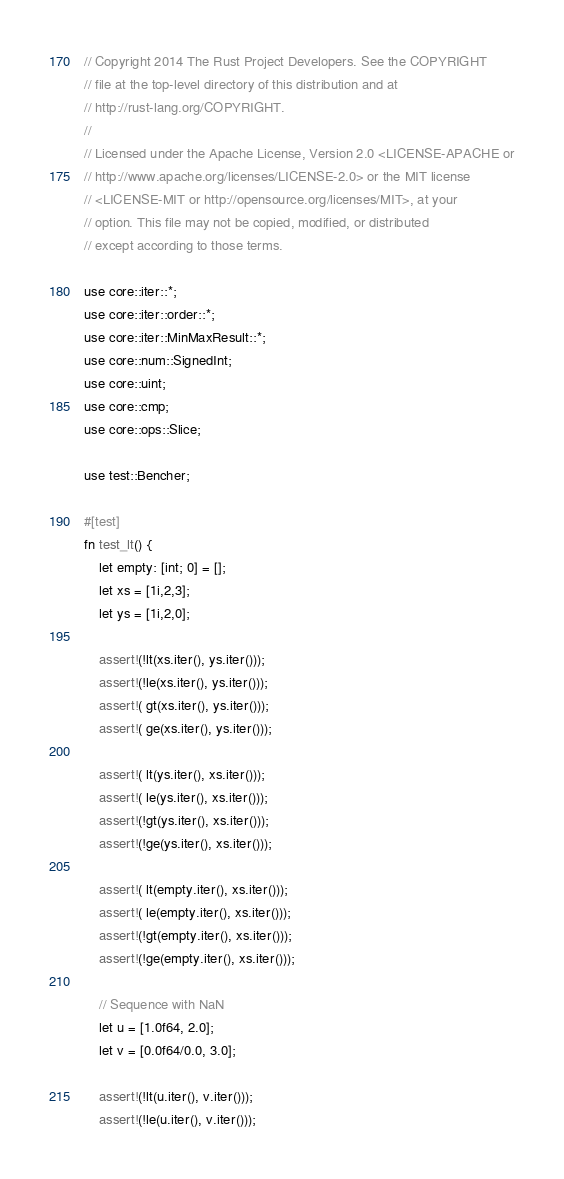Convert code to text. <code><loc_0><loc_0><loc_500><loc_500><_Rust_>// Copyright 2014 The Rust Project Developers. See the COPYRIGHT
// file at the top-level directory of this distribution and at
// http://rust-lang.org/COPYRIGHT.
//
// Licensed under the Apache License, Version 2.0 <LICENSE-APACHE or
// http://www.apache.org/licenses/LICENSE-2.0> or the MIT license
// <LICENSE-MIT or http://opensource.org/licenses/MIT>, at your
// option. This file may not be copied, modified, or distributed
// except according to those terms.

use core::iter::*;
use core::iter::order::*;
use core::iter::MinMaxResult::*;
use core::num::SignedInt;
use core::uint;
use core::cmp;
use core::ops::Slice;

use test::Bencher;

#[test]
fn test_lt() {
    let empty: [int; 0] = [];
    let xs = [1i,2,3];
    let ys = [1i,2,0];

    assert!(!lt(xs.iter(), ys.iter()));
    assert!(!le(xs.iter(), ys.iter()));
    assert!( gt(xs.iter(), ys.iter()));
    assert!( ge(xs.iter(), ys.iter()));

    assert!( lt(ys.iter(), xs.iter()));
    assert!( le(ys.iter(), xs.iter()));
    assert!(!gt(ys.iter(), xs.iter()));
    assert!(!ge(ys.iter(), xs.iter()));

    assert!( lt(empty.iter(), xs.iter()));
    assert!( le(empty.iter(), xs.iter()));
    assert!(!gt(empty.iter(), xs.iter()));
    assert!(!ge(empty.iter(), xs.iter()));

    // Sequence with NaN
    let u = [1.0f64, 2.0];
    let v = [0.0f64/0.0, 3.0];

    assert!(!lt(u.iter(), v.iter()));
    assert!(!le(u.iter(), v.iter()));</code> 